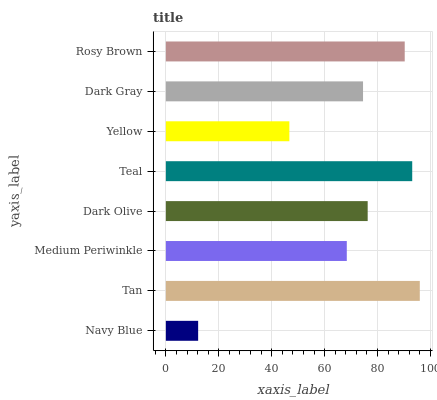Is Navy Blue the minimum?
Answer yes or no. Yes. Is Tan the maximum?
Answer yes or no. Yes. Is Medium Periwinkle the minimum?
Answer yes or no. No. Is Medium Periwinkle the maximum?
Answer yes or no. No. Is Tan greater than Medium Periwinkle?
Answer yes or no. Yes. Is Medium Periwinkle less than Tan?
Answer yes or no. Yes. Is Medium Periwinkle greater than Tan?
Answer yes or no. No. Is Tan less than Medium Periwinkle?
Answer yes or no. No. Is Dark Olive the high median?
Answer yes or no. Yes. Is Dark Gray the low median?
Answer yes or no. Yes. Is Medium Periwinkle the high median?
Answer yes or no. No. Is Tan the low median?
Answer yes or no. No. 